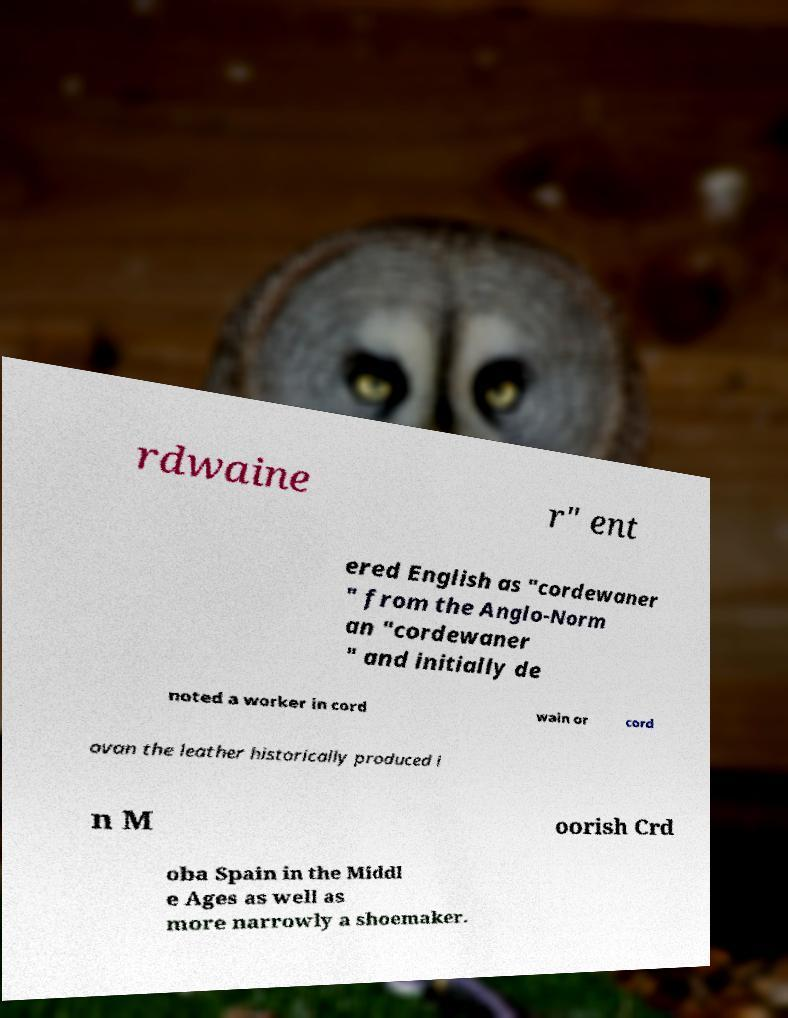Please read and relay the text visible in this image. What does it say? rdwaine r" ent ered English as "cordewaner " from the Anglo-Norm an "cordewaner " and initially de noted a worker in cord wain or cord ovan the leather historically produced i n M oorish Crd oba Spain in the Middl e Ages as well as more narrowly a shoemaker. 